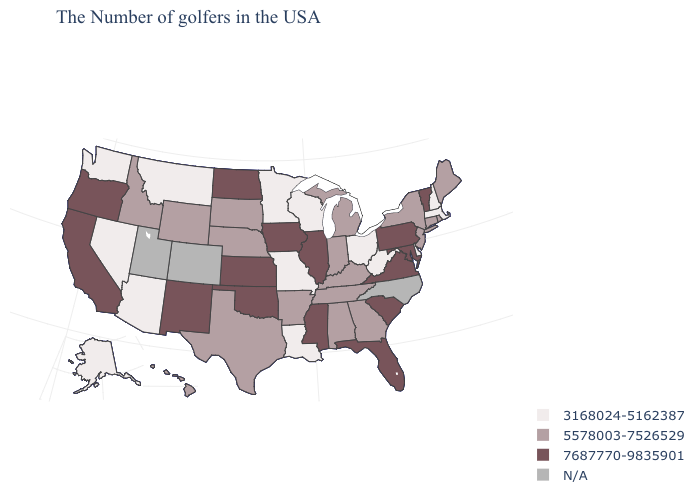What is the value of South Carolina?
Concise answer only. 7687770-9835901. How many symbols are there in the legend?
Concise answer only. 4. What is the highest value in the MidWest ?
Write a very short answer. 7687770-9835901. What is the value of California?
Give a very brief answer. 7687770-9835901. What is the value of Vermont?
Concise answer only. 7687770-9835901. Name the states that have a value in the range N/A?
Quick response, please. North Carolina, Colorado, Utah. What is the value of Minnesota?
Give a very brief answer. 3168024-5162387. Among the states that border Rhode Island , which have the lowest value?
Give a very brief answer. Massachusetts. Among the states that border North Carolina , does Tennessee have the lowest value?
Be succinct. Yes. Among the states that border Illinois , does Iowa have the highest value?
Answer briefly. Yes. Which states have the highest value in the USA?
Be succinct. Vermont, Maryland, Pennsylvania, Virginia, South Carolina, Florida, Illinois, Mississippi, Iowa, Kansas, Oklahoma, North Dakota, New Mexico, California, Oregon. What is the value of Mississippi?
Give a very brief answer. 7687770-9835901. 